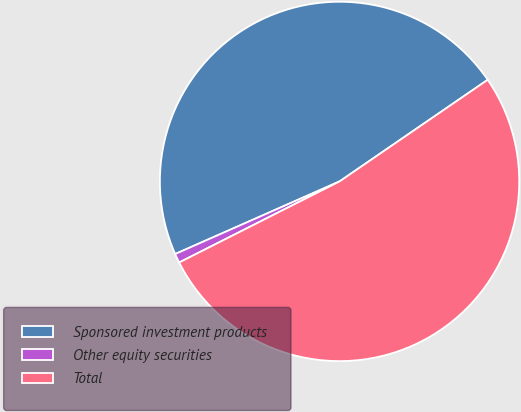Convert chart. <chart><loc_0><loc_0><loc_500><loc_500><pie_chart><fcel>Sponsored investment products<fcel>Other equity securities<fcel>Total<nl><fcel>47.05%<fcel>0.83%<fcel>52.12%<nl></chart> 